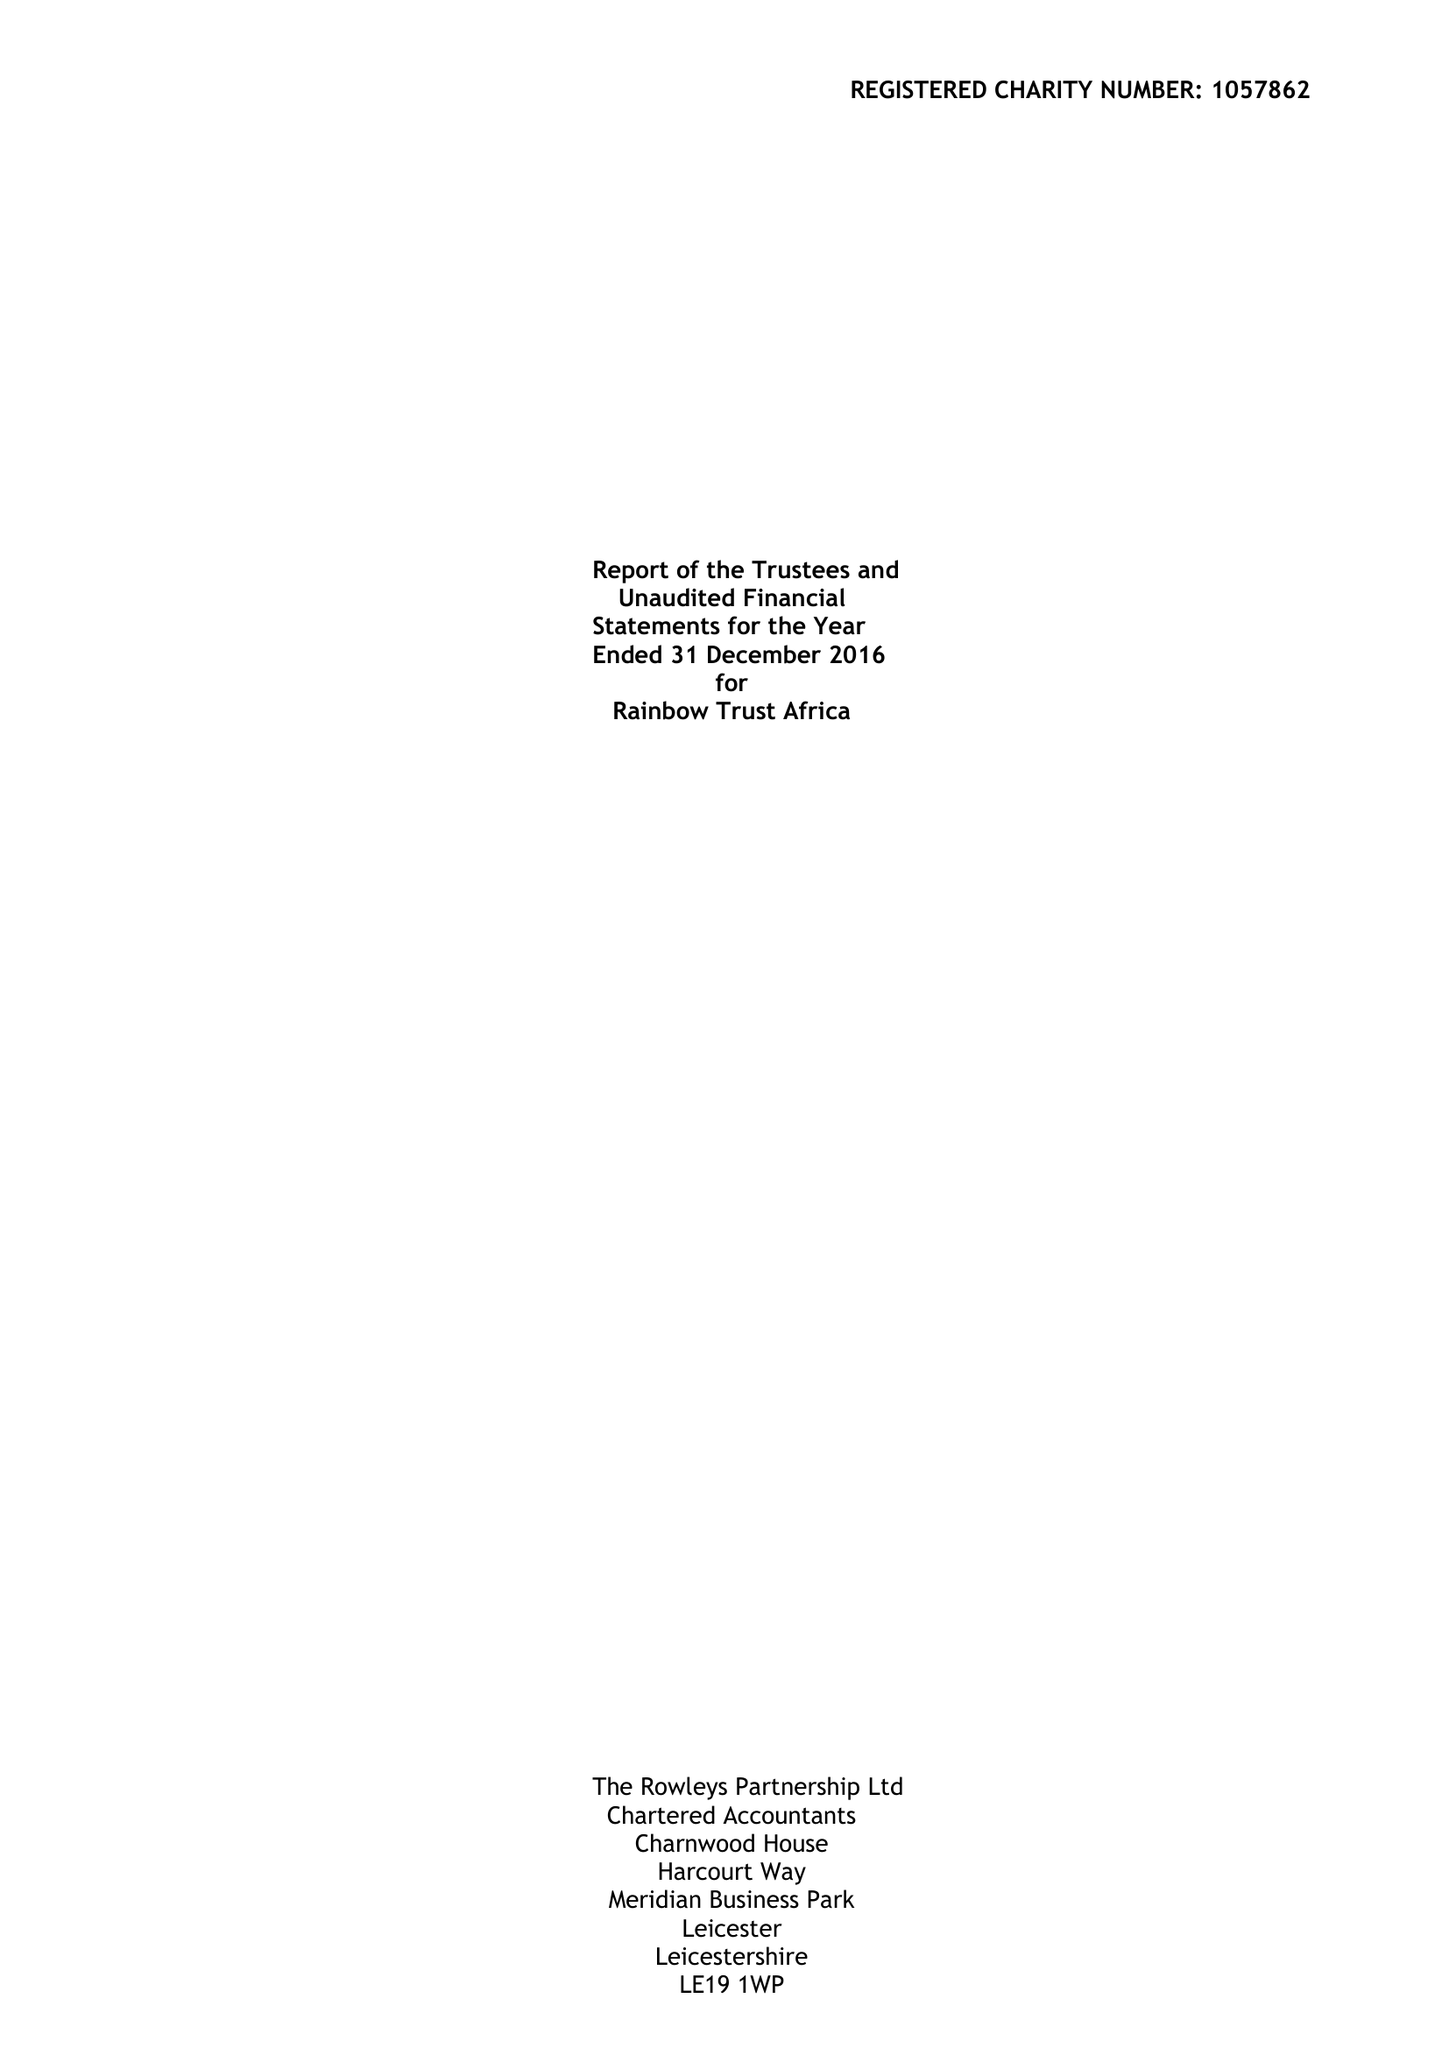What is the value for the income_annually_in_british_pounds?
Answer the question using a single word or phrase. 254330.00 